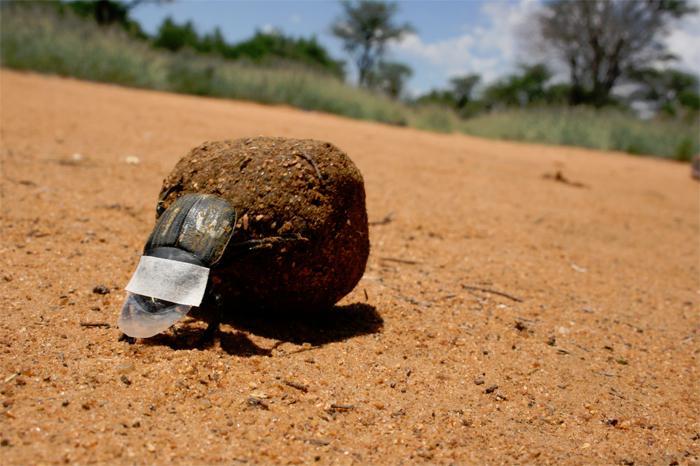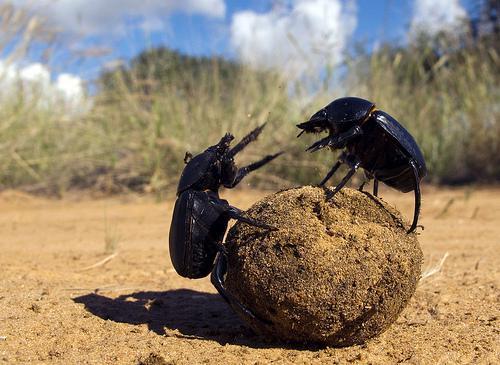The first image is the image on the left, the second image is the image on the right. Given the left and right images, does the statement "There is one beetle that is not touching a ball of dung." hold true? Answer yes or no. No. 